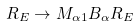Convert formula to latex. <formula><loc_0><loc_0><loc_500><loc_500>R _ { E } \rightarrow M _ { \alpha 1 } B _ { \alpha } R _ { E }</formula> 